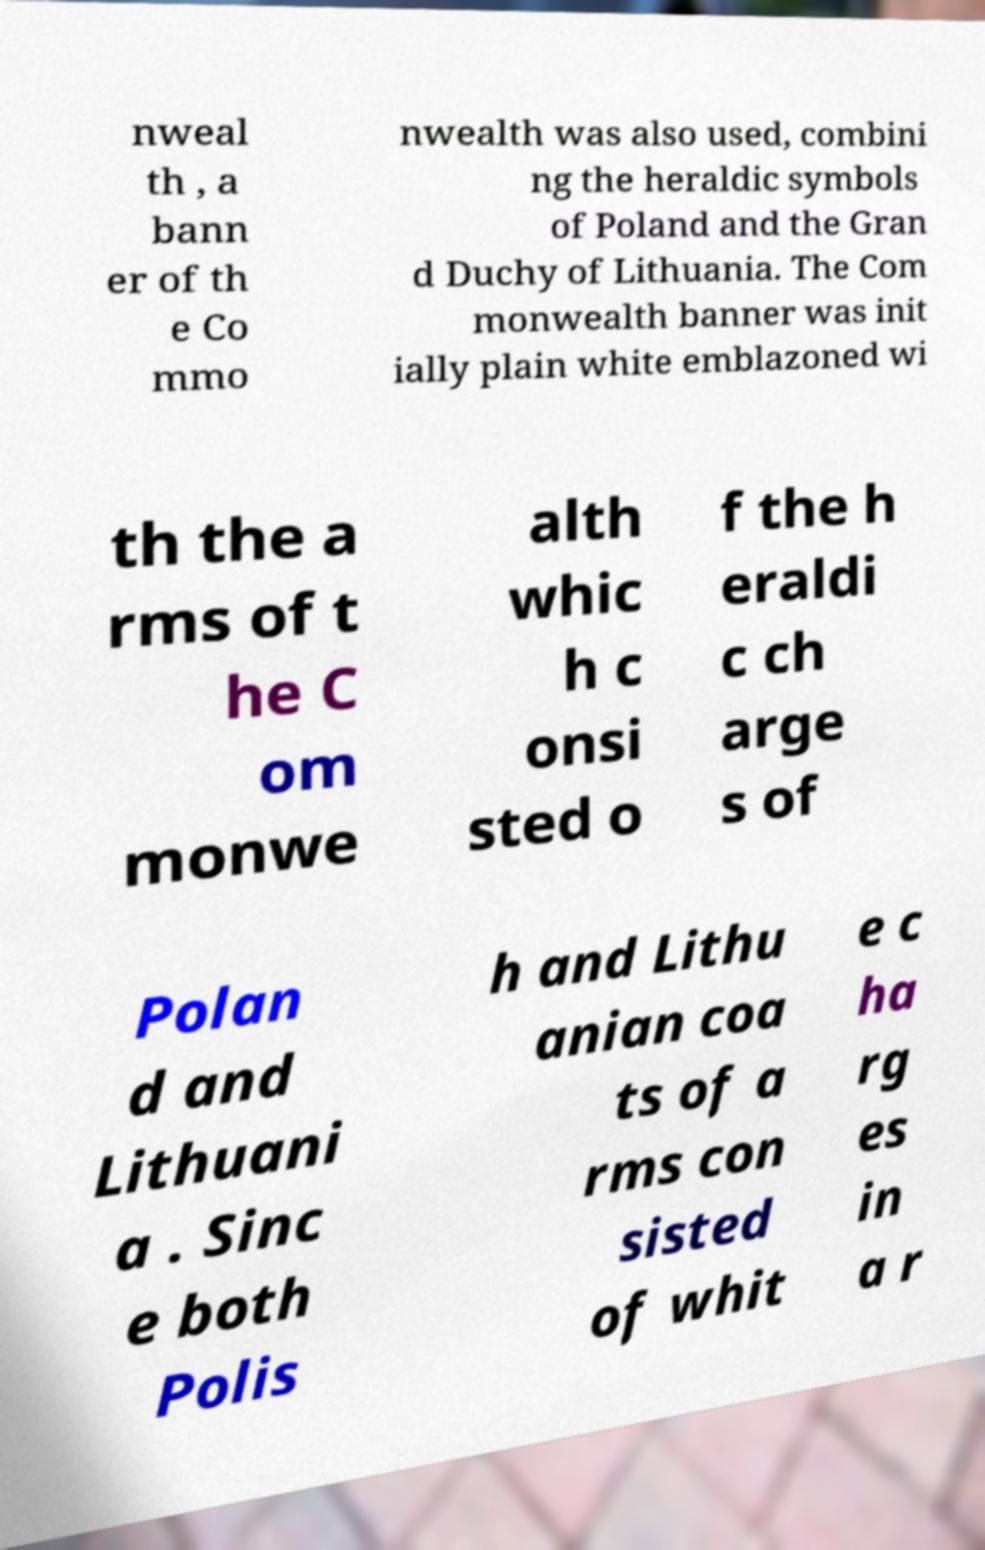Please read and relay the text visible in this image. What does it say? nweal th , a bann er of th e Co mmo nwealth was also used, combini ng the heraldic symbols of Poland and the Gran d Duchy of Lithuania. The Com monwealth banner was init ially plain white emblazoned wi th the a rms of t he C om monwe alth whic h c onsi sted o f the h eraldi c ch arge s of Polan d and Lithuani a . Sinc e both Polis h and Lithu anian coa ts of a rms con sisted of whit e c ha rg es in a r 